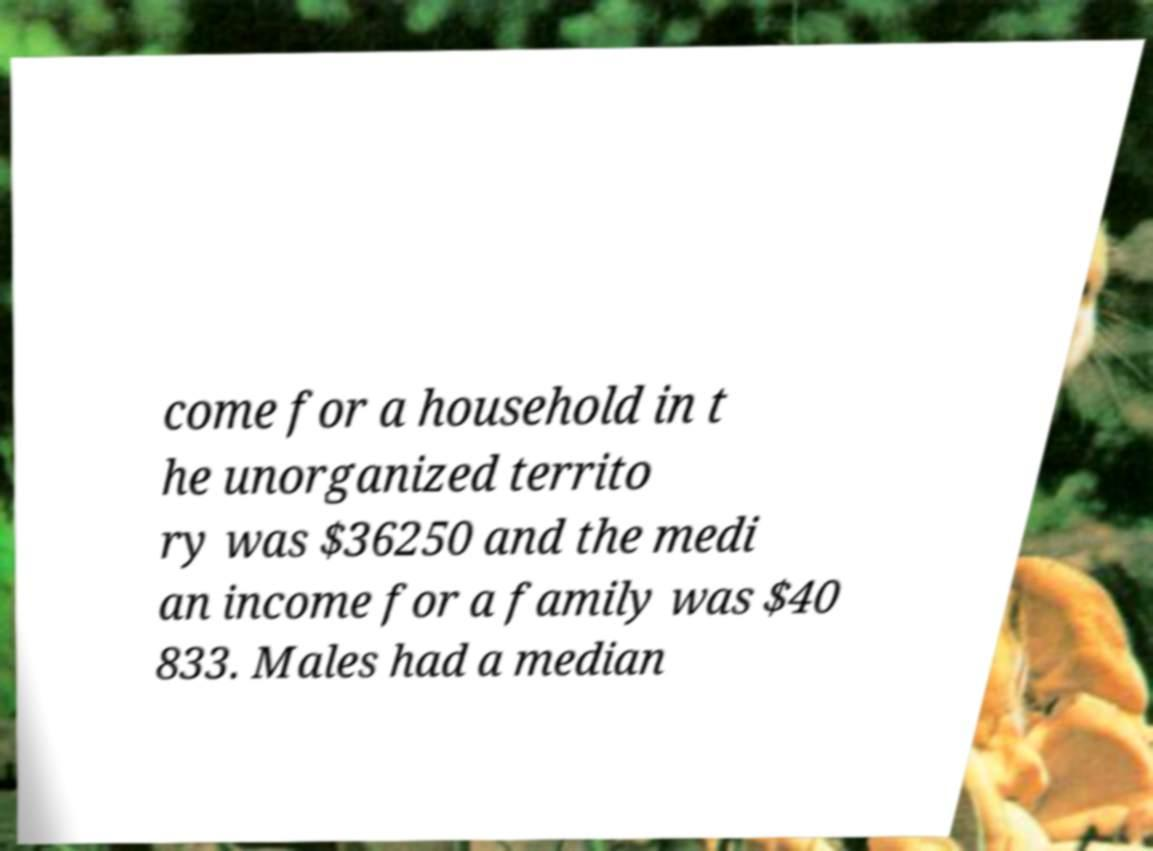I need the written content from this picture converted into text. Can you do that? come for a household in t he unorganized territo ry was $36250 and the medi an income for a family was $40 833. Males had a median 